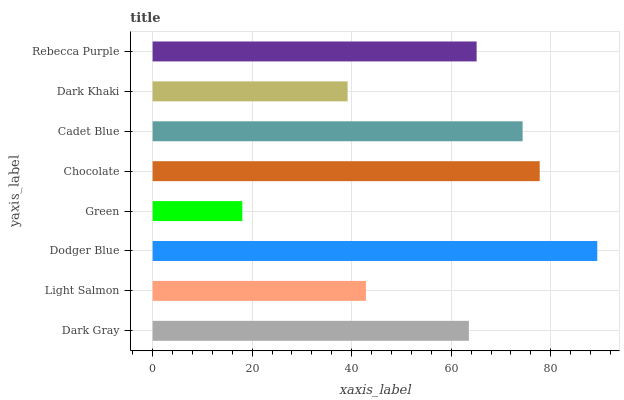Is Green the minimum?
Answer yes or no. Yes. Is Dodger Blue the maximum?
Answer yes or no. Yes. Is Light Salmon the minimum?
Answer yes or no. No. Is Light Salmon the maximum?
Answer yes or no. No. Is Dark Gray greater than Light Salmon?
Answer yes or no. Yes. Is Light Salmon less than Dark Gray?
Answer yes or no. Yes. Is Light Salmon greater than Dark Gray?
Answer yes or no. No. Is Dark Gray less than Light Salmon?
Answer yes or no. No. Is Rebecca Purple the high median?
Answer yes or no. Yes. Is Dark Gray the low median?
Answer yes or no. Yes. Is Cadet Blue the high median?
Answer yes or no. No. Is Dark Khaki the low median?
Answer yes or no. No. 